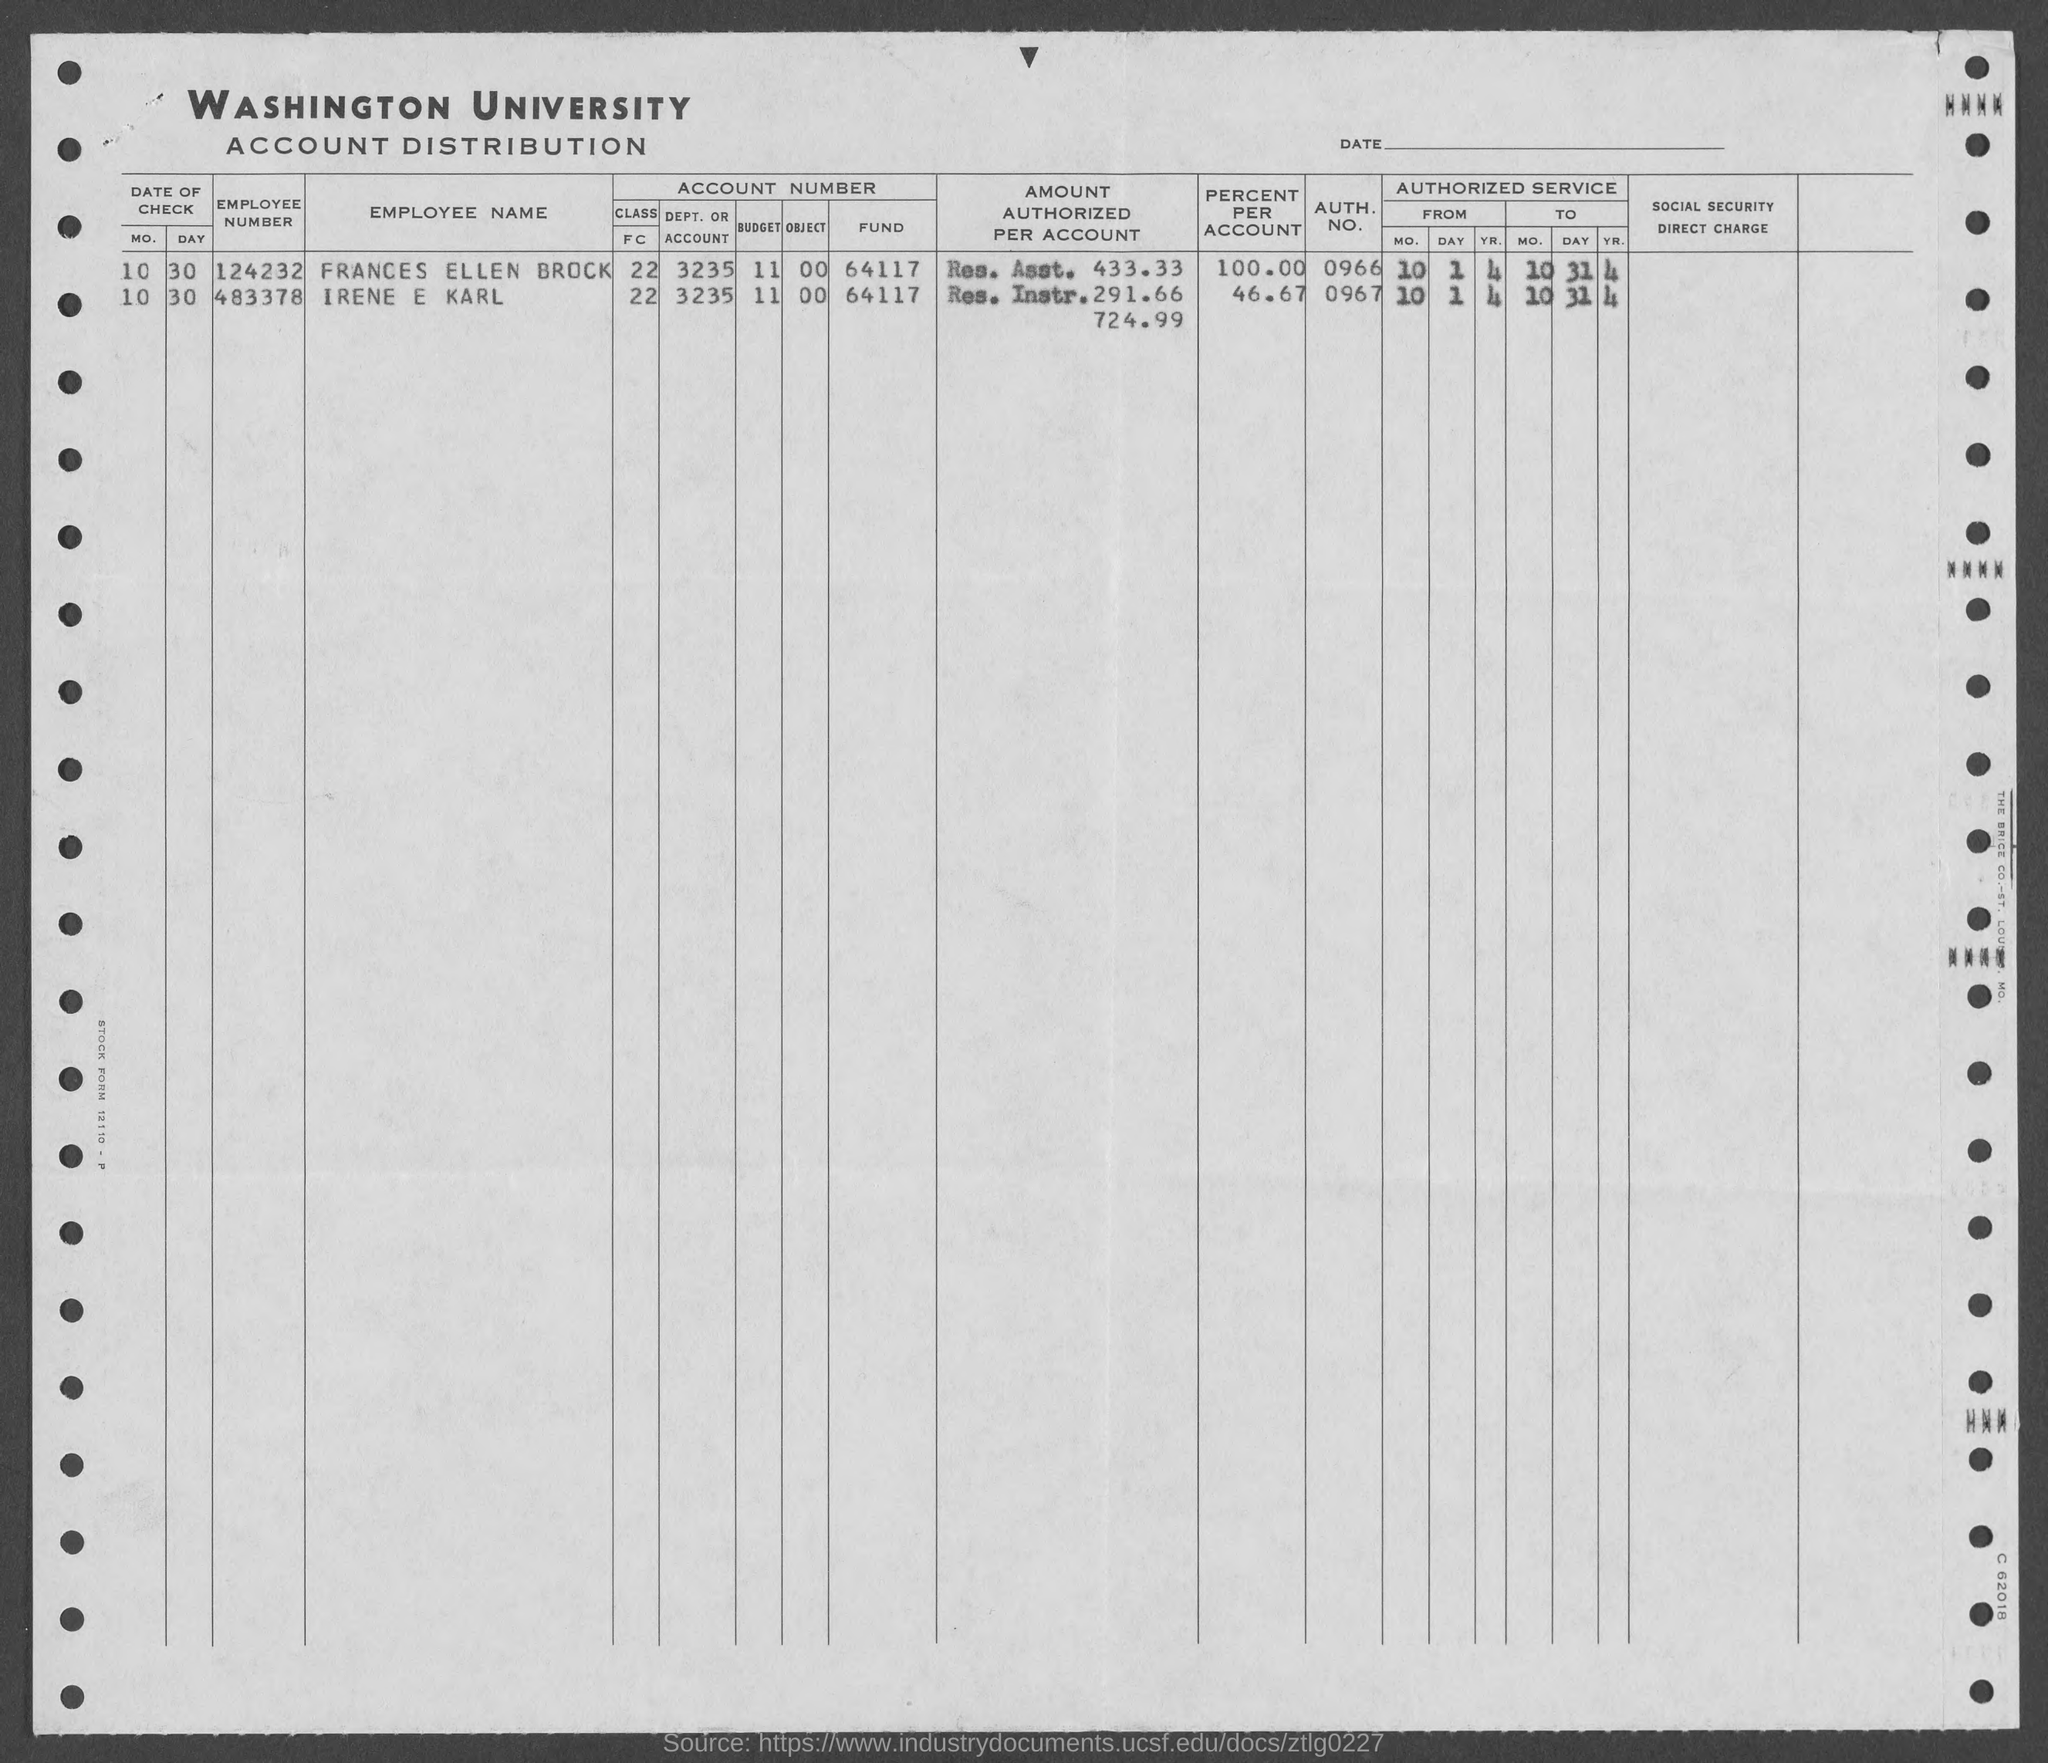What does 'Res. Instr.' stand for, which is mentioned in the 'AMOUNT AUTHORIZED PER ACCOUNT' section? The term 'Res. Instr.' likely stands for 'Research Instruction' or a similar concept, referring to the kind of expenses associated with this account in the Washington University Account Distribution record. 